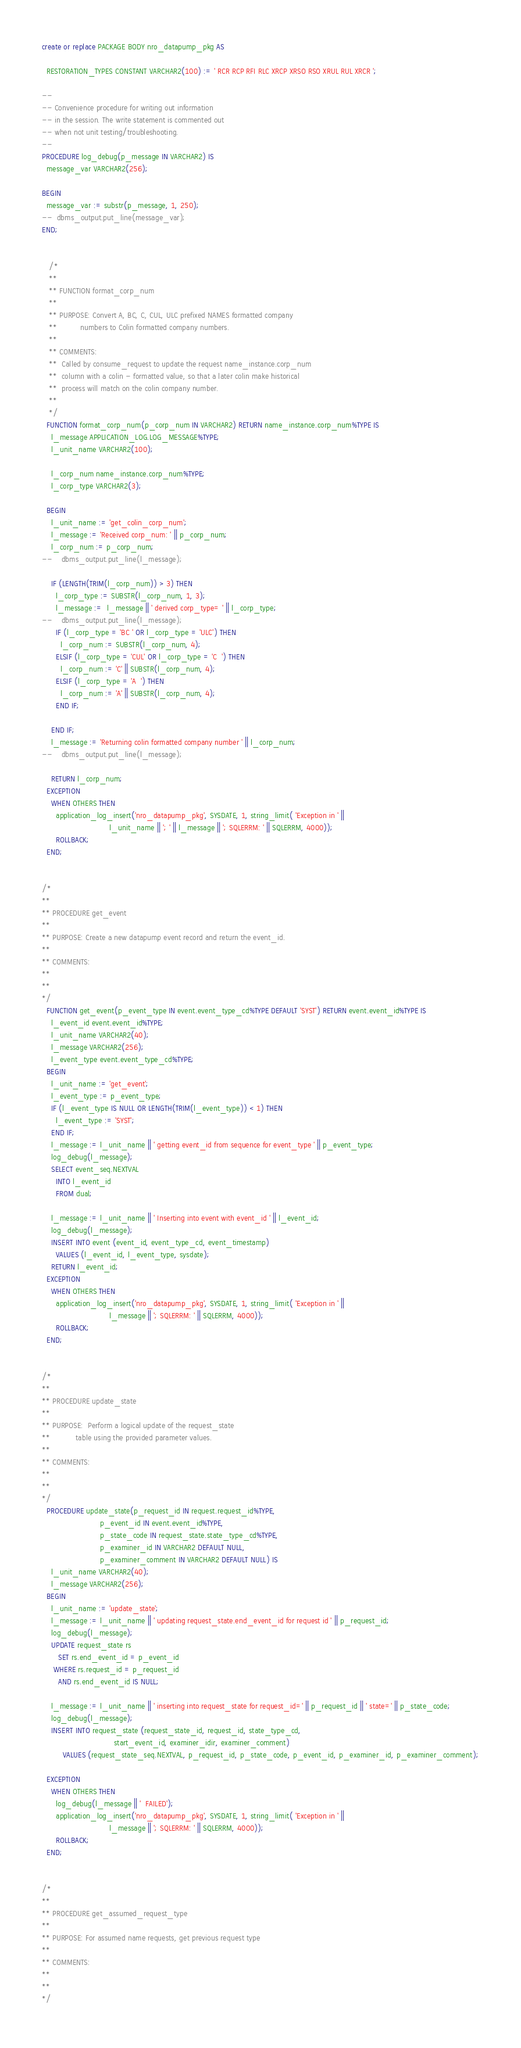<code> <loc_0><loc_0><loc_500><loc_500><_SQL_>create or replace PACKAGE BODY nro_datapump_pkg AS

  RESTORATION_TYPES CONSTANT VARCHAR2(100) := ' RCR RCP RFI RLC XRCP XRSO RSO XRUL RUL XRCR ';

--
-- Convenience procedure for writing out information
-- in the session. The write statement is commented out
-- when not unit testing/troubleshooting.
--
PROCEDURE log_debug(p_message IN VARCHAR2) IS
  message_var VARCHAR2(256);

BEGIN
  message_var := substr(p_message, 1, 250);
--  dbms_output.put_line(message_var);
END;


   /*
   **
   ** FUNCTION format_corp_num
   **
   ** PURPOSE: Convert A, BC, C, CUL, ULC prefixed NAMES formatted company
   **          numbers to Colin formatted company numbers.
   **
   ** COMMENTS:
   **  Called by consume_request to update the request name_instance.corp_num
   **  column with a colin - formatted value, so that a later colin make historical
   **  process will match on the colin company number.
   **
   */
  FUNCTION format_corp_num(p_corp_num IN VARCHAR2) RETURN name_instance.corp_num%TYPE IS
    l_message APPLICATION_LOG.LOG_MESSAGE%TYPE;
    l_unit_name VARCHAR2(100);

    l_corp_num name_instance.corp_num%TYPE;
    l_corp_type VARCHAR2(3);

  BEGIN
    l_unit_name := 'get_colin_corp_num';
    l_message := 'Received corp_num: ' || p_corp_num;
    l_corp_num := p_corp_num;
--    dbms_output.put_line(l_message);

    IF (LENGTH(TRIM(l_corp_num)) > 3) THEN
      l_corp_type := SUBSTR(l_corp_num, 1, 3);
      l_message :=  l_message || ' derived corp_type= ' || l_corp_type;
--    dbms_output.put_line(l_message);
      IF (l_corp_type = 'BC ' OR l_corp_type = 'ULC') THEN
        l_corp_num := SUBSTR(l_corp_num, 4);
      ELSIF (l_corp_type = 'CUL' OR l_corp_type = 'C  ') THEN
        l_corp_num := 'C' || SUBSTR(l_corp_num, 4);
      ELSIF (l_corp_type = 'A  ') THEN
        l_corp_num := 'A' || SUBSTR(l_corp_num, 4);
      END IF;

    END IF;
    l_message := 'Returning colin formatted company number ' || l_corp_num;
--    dbms_output.put_line(l_message);

    RETURN l_corp_num;
  EXCEPTION
    WHEN OTHERS THEN
      application_log_insert('nro_datapump_pkg', SYSDATE, 1, string_limit( 'Exception in ' ||
                             l_unit_name || '; ' || l_message || '; SQLERRM: ' || SQLERRM, 4000));
      ROLLBACK;
  END;


/*
**
** PROCEDURE get_event
**
** PURPOSE: Create a new datapump event record and return the event_id.
**
** COMMENTS:
**
**
*/
  FUNCTION get_event(p_event_type IN event.event_type_cd%TYPE DEFAULT 'SYST') RETURN event.event_id%TYPE IS
    l_event_id event.event_id%TYPE;
    l_unit_name VARCHAR2(40);
    l_message VARCHAR2(256);
    l_event_type event.event_type_cd%TYPE;
  BEGIN
    l_unit_name := 'get_event';
    l_event_type := p_event_type;
    IF (l_event_type IS NULL OR LENGTH(TRIM(l_event_type)) < 1) THEN
      l_event_type := 'SYST';
    END IF;
    l_message := l_unit_name || ' getting event_id from sequence for event_type ' || p_event_type;
    log_debug(l_message);
    SELECT event_seq.NEXTVAL
      INTO l_event_id
      FROM dual;

    l_message := l_unit_name || ' Inserting into event with event_id ' || l_event_id;
    log_debug(l_message);
    INSERT INTO event (event_id, event_type_cd, event_timestamp)
      VALUES (l_event_id, l_event_type, sysdate);
    RETURN l_event_id;
  EXCEPTION
    WHEN OTHERS THEN
      application_log_insert('nro_datapump_pkg', SYSDATE, 1, string_limit( 'Exception in ' ||
                             l_message || '; SQLERRM: ' || SQLERRM, 4000));
      ROLLBACK;
  END;


/*
**
** PROCEDURE update_state
**
** PURPOSE:  Perform a logical update of the request_state
**           table using the provided parameter values.
**
** COMMENTS:
**
**
*/
  PROCEDURE update_state(p_request_id IN request.request_id%TYPE,
                         p_event_id IN event.event_id%TYPE,
                         p_state_code IN request_state.state_type_cd%TYPE,
                         p_examiner_id IN VARCHAR2 DEFAULT NULL,
                         p_examiner_comment IN VARCHAR2 DEFAULT NULL) IS
    l_unit_name VARCHAR2(40);
    l_message VARCHAR2(256);
  BEGIN
    l_unit_name := 'update_state';
    l_message := l_unit_name || ' updating request_state.end_event_id for request id ' || p_request_id;
    log_debug(l_message);
    UPDATE request_state rs
       SET rs.end_event_id = p_event_id
     WHERE rs.request_id = p_request_id
       AND rs.end_event_id IS NULL;

    l_message := l_unit_name || ' inserting into request_state for request_id=' || p_request_id || ' state=' || p_state_code;
    log_debug(l_message);
    INSERT INTO request_state (request_state_id, request_id, state_type_cd,
                               start_event_id, examiner_idir, examiner_comment)
         VALUES (request_state_seq.NEXTVAL, p_request_id, p_state_code, p_event_id, p_examiner_id, p_examiner_comment);

  EXCEPTION
    WHEN OTHERS THEN
      log_debug(l_message || '  FAILED');
      application_log_insert('nro_datapump_pkg', SYSDATE, 1, string_limit( 'Exception in ' ||
                             l_message || '; SQLERRM: ' || SQLERRM, 4000));
      ROLLBACK;
  END;


/*
**
** PROCEDURE get_assumed_request_type
**
** PURPOSE: For assumed name requests, get previous request type
**
** COMMENTS:
**
**
*/</code> 